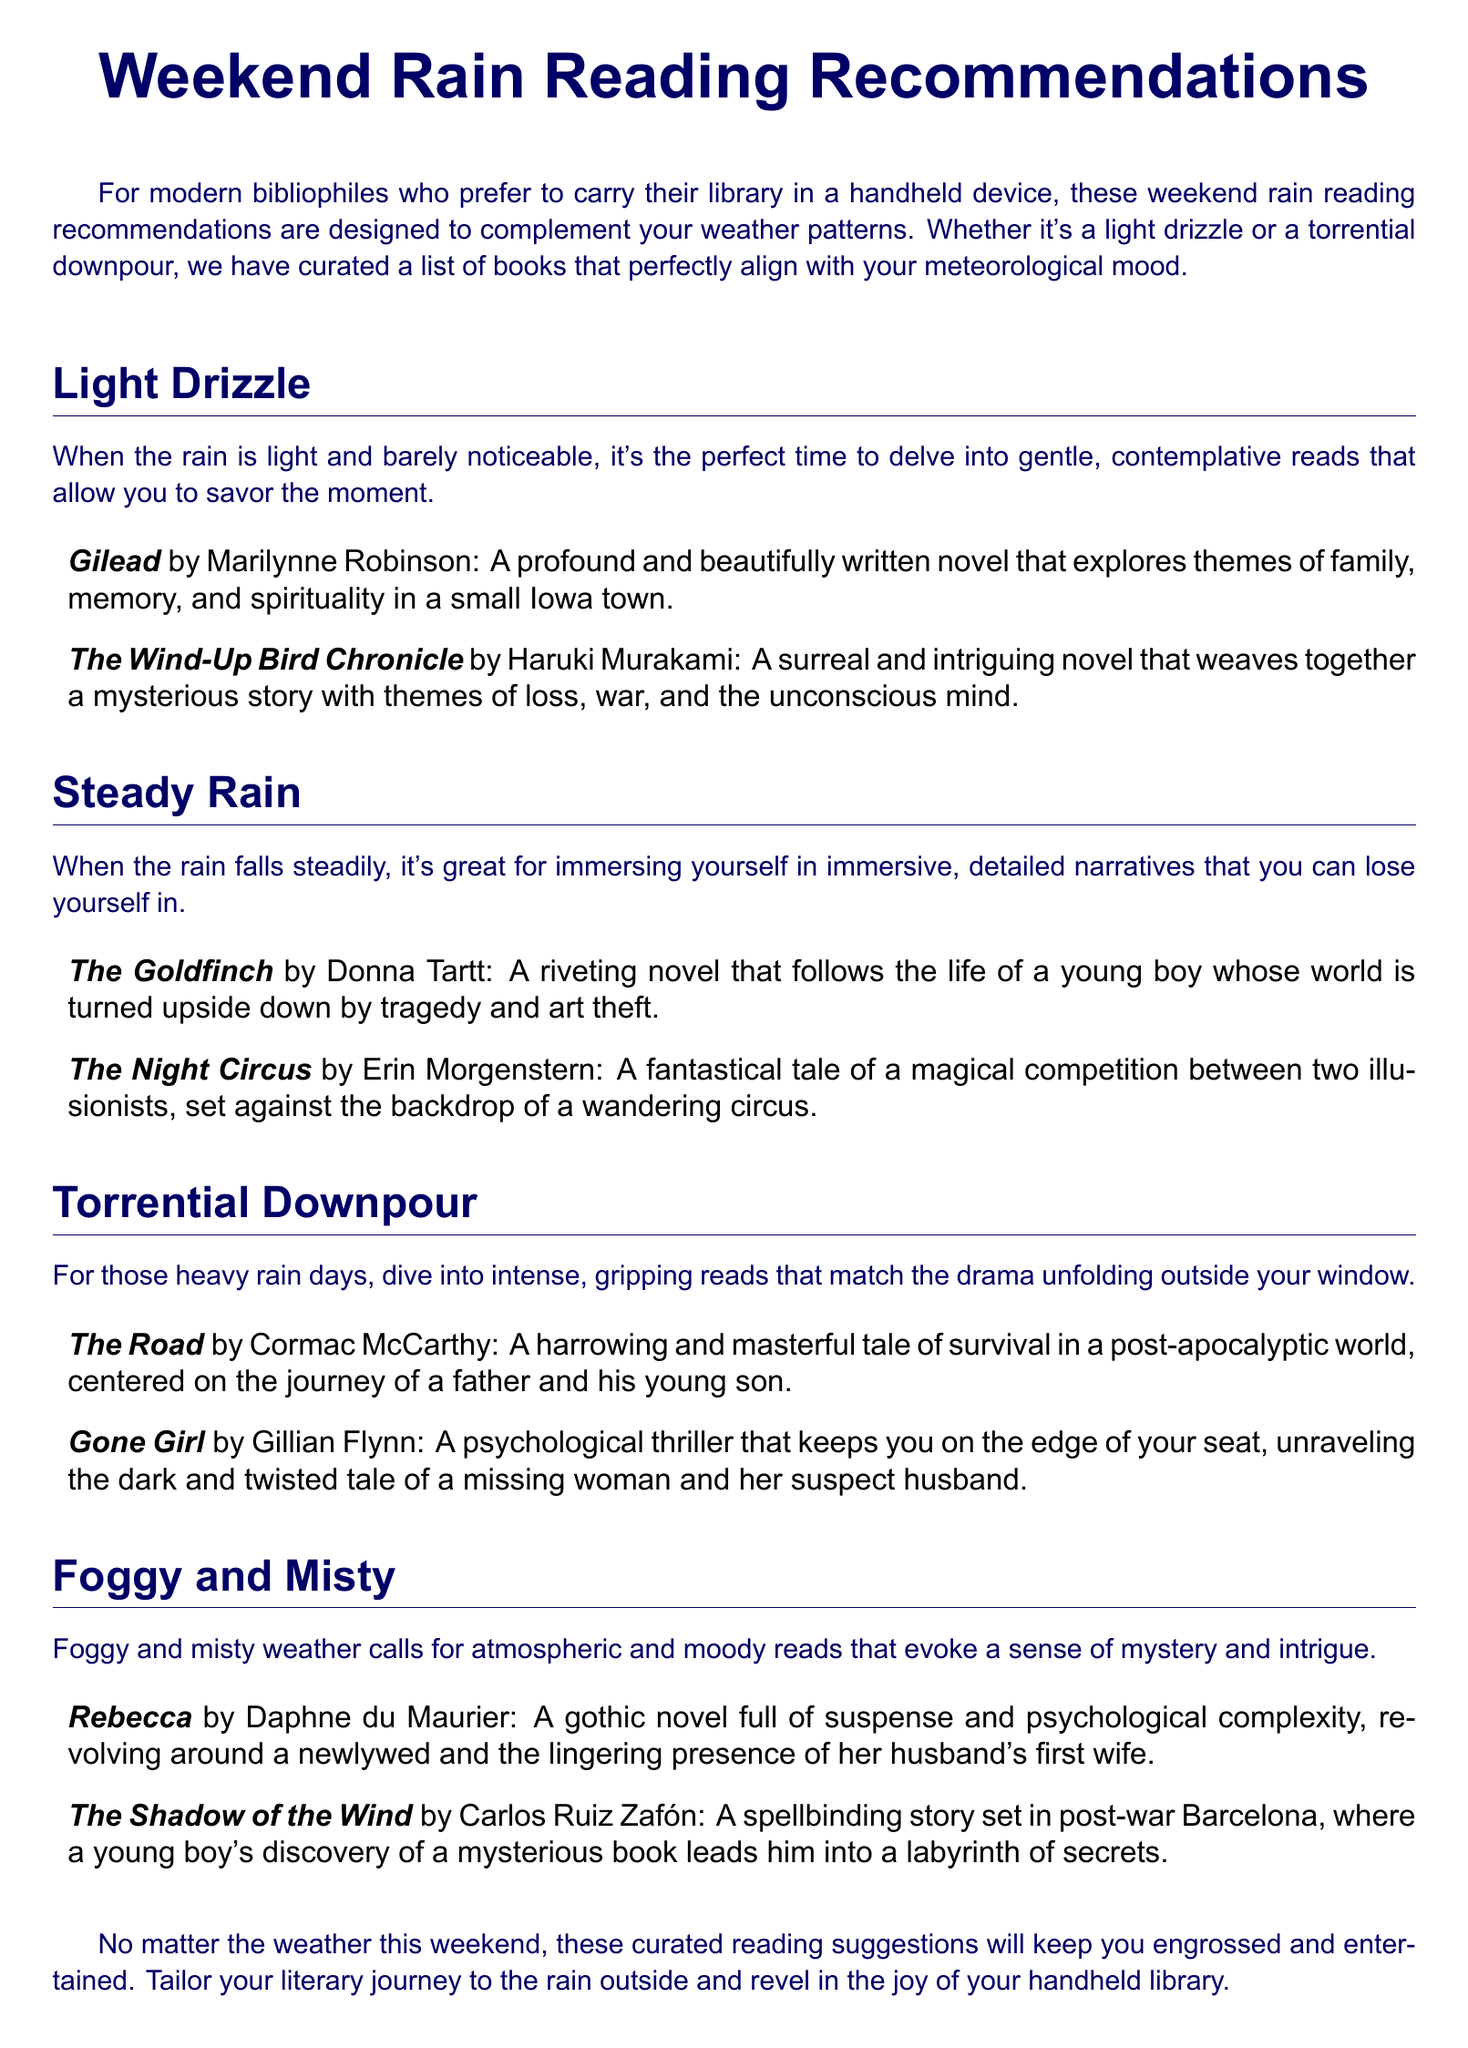What is the title of the document? The title of the document is stated prominently at the top, indicating the main theme of the recommendations.
Answer: Weekend Rain Reading Recommendations How many sections are in the document? The document has multiple sections based on different weather patterns, each with its own theme and recommendations.
Answer: Four Who is the author of *Gilead*? The author of *Gilead* is listed in the recommendations section where the book is mentioned.
Answer: Marilynne Robinson What type of read is suggested for foggy and misty weather? This information is provided in the section that describes the atmospheric and moody reads needed for foggy and misty conditions.
Answer: Atmospheric and moody reads Which book is recommended for steady rain? The specific book recommended for steady rain can be found in the section detailing readings appropriate for that weather condition.
Answer: The Goldfinch What mood does *Gone Girl* evoke? The description of *Gone Girl* suggests the type of emotional response it elicits related to its thrilling nature in the document.
Answer: Intense and gripping In which weather condition is *The Night Circus* recommended? The meteorological condition for which *The Night Circus* is suggested can be found under the relevant section.
Answer: Steady Rain What genre does *Rebecca* belong to? The genre is stated in the description provided for *Rebecca* in its respective section.
Answer: Gothic novel Which book features a journey of a father and son? This book is mentioned in the context of overwhelming weather and relates to themes of survival, indicated in the relevant section.
Answer: The Road 